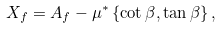<formula> <loc_0><loc_0><loc_500><loc_500>X _ { f } = A _ { f } - \mu ^ { \ast } \left \{ \cot \beta , \tan \beta \right \} ,</formula> 